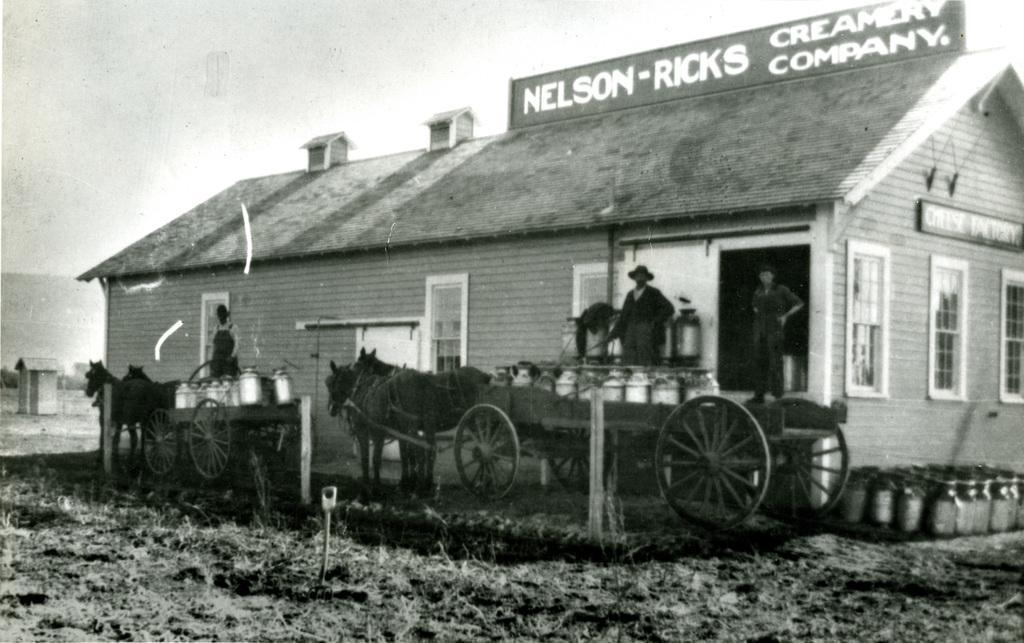How would you summarize this image in a sentence or two? This is black and white picture, in this picture there are people and we can see horse carts, poles and house. We can see a board on top of a house. In the background of the image we can see a shed and sky. 